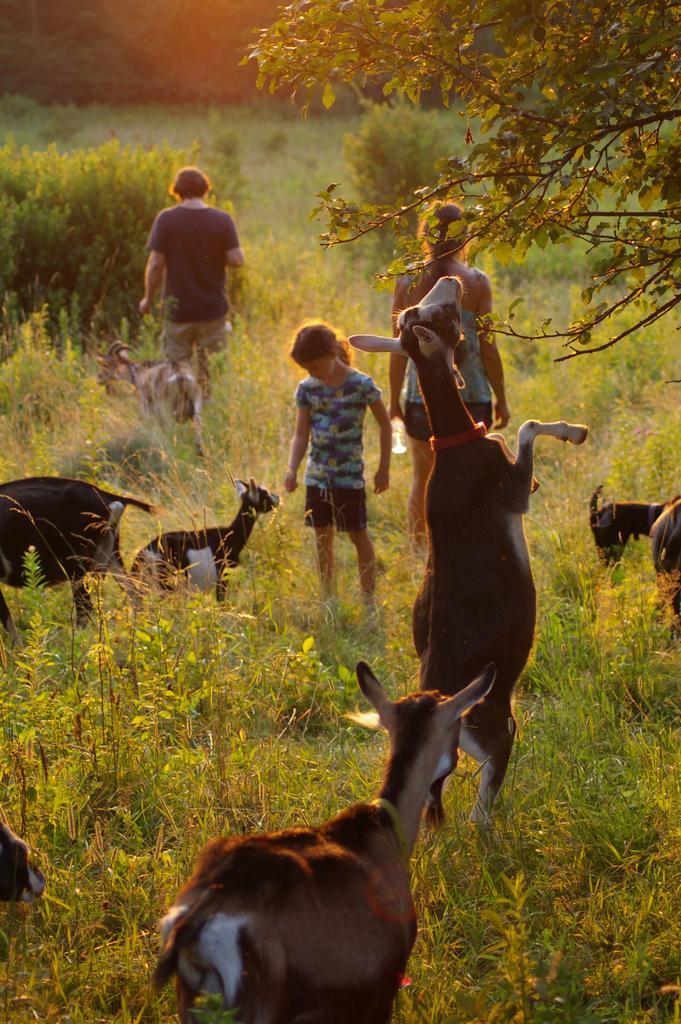Please provide a concise description of this image. In this image there are people. There are animals. At the bottom of the image there is grass. To the right side of the image there is a tree. 